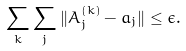<formula> <loc_0><loc_0><loc_500><loc_500>\sum _ { k } \sum _ { j } \| A ^ { ( k ) } _ { j } - a _ { j } \| \leq \epsilon .</formula> 